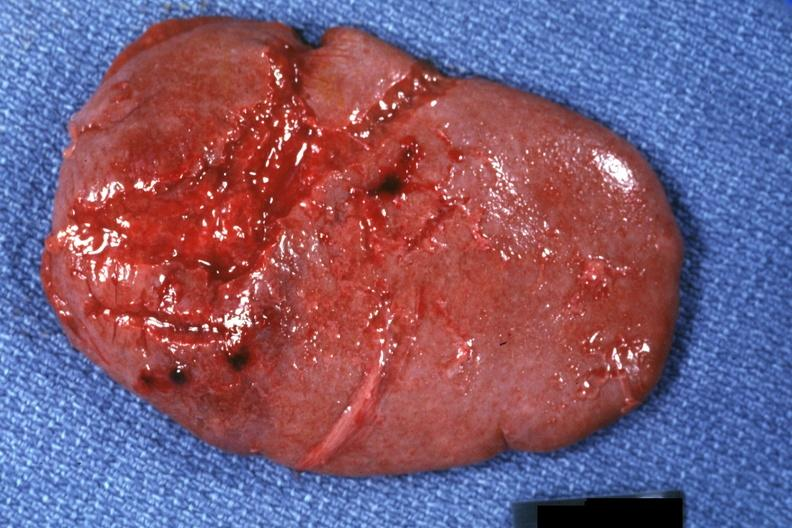where is this part in?
Answer the question using a single word or phrase. Spleen 